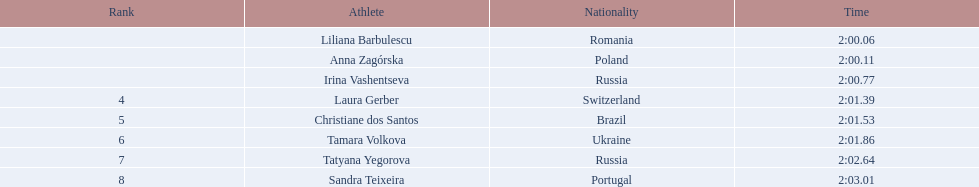What was the time difference between the first place finisher and the eighth place finisher? 2.95. Would you be able to parse every entry in this table? {'header': ['Rank', 'Athlete', 'Nationality', 'Time'], 'rows': [['', 'Liliana Barbulescu', 'Romania', '2:00.06'], ['', 'Anna Zagórska', 'Poland', '2:00.11'], ['', 'Irina Vashentseva', 'Russia', '2:00.77'], ['4', 'Laura Gerber', 'Switzerland', '2:01.39'], ['5', 'Christiane dos Santos', 'Brazil', '2:01.53'], ['6', 'Tamara Volkova', 'Ukraine', '2:01.86'], ['7', 'Tatyana Yegorova', 'Russia', '2:02.64'], ['8', 'Sandra Teixeira', 'Portugal', '2:03.01']]} 